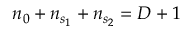<formula> <loc_0><loc_0><loc_500><loc_500>n _ { 0 } + n _ { s _ { 1 } } + n _ { s _ { 2 } } = D + 1</formula> 